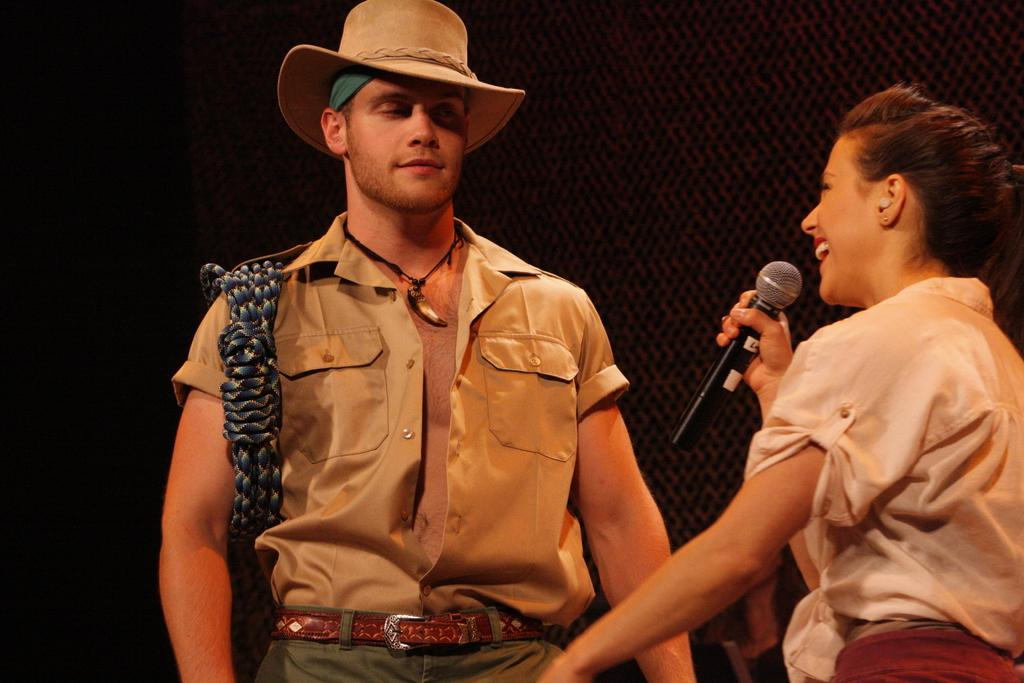What is the lady in the image holding? The lady is holding a mic in the image. On which side of the image is the lady holding the mic? The lady is on the right side of the image. Can you describe the person next to the lady holding the mic? There is a person wearing a hat beside the lady holding the mic. Is the lady wearing a crown in the image? No, the lady is not wearing a crown in the image; she is holding a mic. Can you see a giraffe in the image? No, there is no giraffe present in the image. 